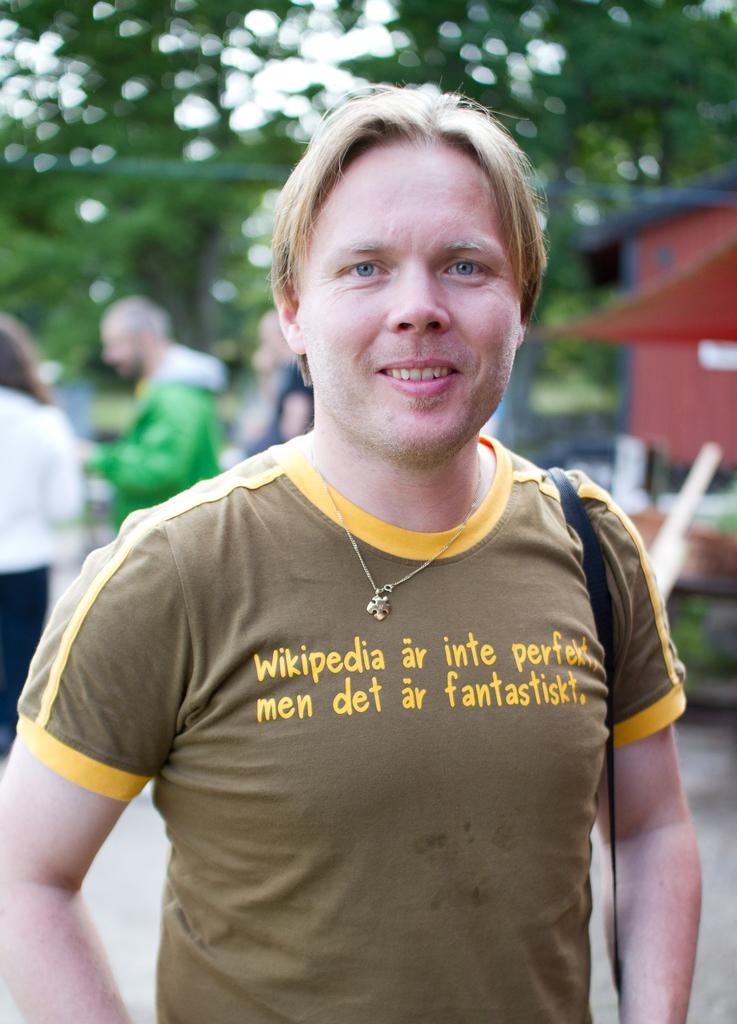What is the main subject of the image? There is a person standing in the image. Can you describe the surroundings of the person? There are other people visible in the background of the image, and there are trees in the background as well. What type of bubble can be seen floating near the person in the image? There is no bubble present in the image. 